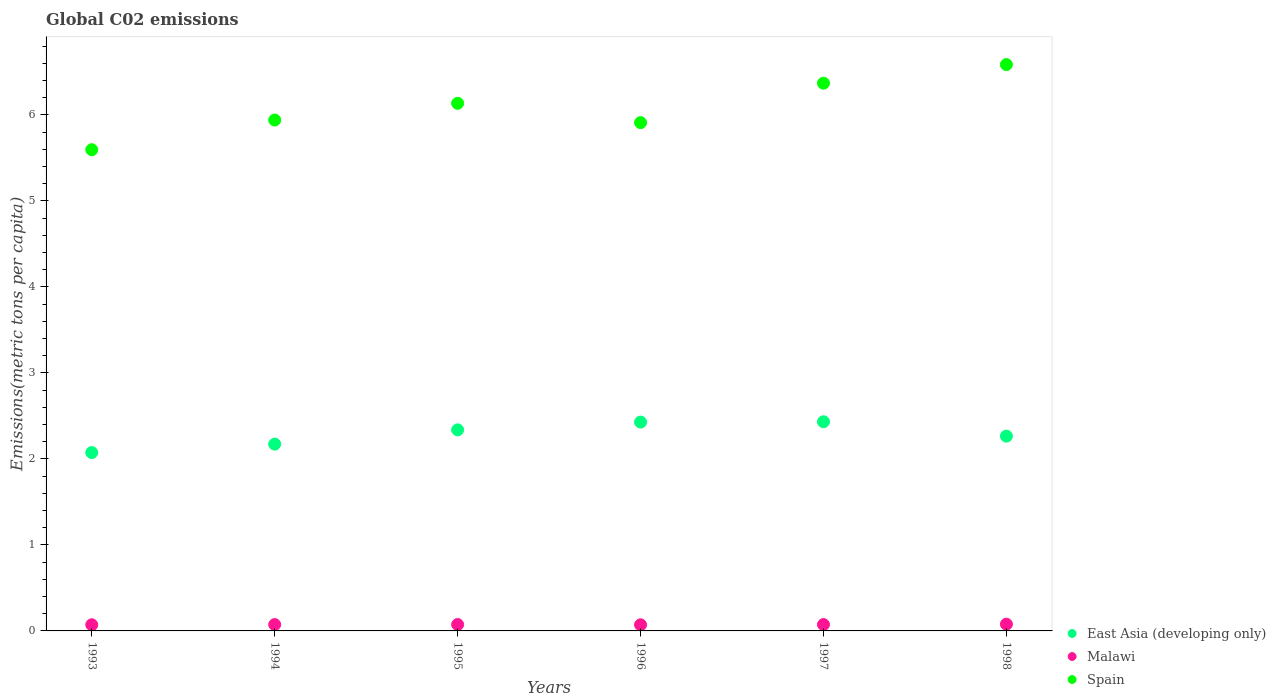How many different coloured dotlines are there?
Offer a very short reply. 3. What is the amount of CO2 emitted in in East Asia (developing only) in 1996?
Keep it short and to the point. 2.43. Across all years, what is the maximum amount of CO2 emitted in in Spain?
Your response must be concise. 6.58. Across all years, what is the minimum amount of CO2 emitted in in Malawi?
Ensure brevity in your answer.  0.07. In which year was the amount of CO2 emitted in in Spain maximum?
Offer a very short reply. 1998. What is the total amount of CO2 emitted in in Malawi in the graph?
Your answer should be very brief. 0.44. What is the difference between the amount of CO2 emitted in in Malawi in 1996 and that in 1998?
Your response must be concise. -0.01. What is the difference between the amount of CO2 emitted in in East Asia (developing only) in 1993 and the amount of CO2 emitted in in Malawi in 1998?
Make the answer very short. 2. What is the average amount of CO2 emitted in in East Asia (developing only) per year?
Your answer should be compact. 2.28. In the year 1998, what is the difference between the amount of CO2 emitted in in Malawi and amount of CO2 emitted in in East Asia (developing only)?
Ensure brevity in your answer.  -2.19. In how many years, is the amount of CO2 emitted in in East Asia (developing only) greater than 2.8 metric tons per capita?
Provide a short and direct response. 0. What is the ratio of the amount of CO2 emitted in in East Asia (developing only) in 1993 to that in 1994?
Provide a succinct answer. 0.95. Is the amount of CO2 emitted in in Malawi in 1993 less than that in 1995?
Your answer should be very brief. Yes. What is the difference between the highest and the second highest amount of CO2 emitted in in Malawi?
Give a very brief answer. 0. What is the difference between the highest and the lowest amount of CO2 emitted in in Malawi?
Your answer should be compact. 0.01. Does the amount of CO2 emitted in in Spain monotonically increase over the years?
Give a very brief answer. No. Where does the legend appear in the graph?
Your answer should be compact. Bottom right. What is the title of the graph?
Keep it short and to the point. Global C02 emissions. Does "Costa Rica" appear as one of the legend labels in the graph?
Provide a short and direct response. No. What is the label or title of the Y-axis?
Offer a very short reply. Emissions(metric tons per capita). What is the Emissions(metric tons per capita) in East Asia (developing only) in 1993?
Ensure brevity in your answer.  2.07. What is the Emissions(metric tons per capita) of Malawi in 1993?
Provide a succinct answer. 0.07. What is the Emissions(metric tons per capita) in Spain in 1993?
Give a very brief answer. 5.59. What is the Emissions(metric tons per capita) in East Asia (developing only) in 1994?
Give a very brief answer. 2.17. What is the Emissions(metric tons per capita) in Malawi in 1994?
Your answer should be compact. 0.07. What is the Emissions(metric tons per capita) in Spain in 1994?
Provide a succinct answer. 5.94. What is the Emissions(metric tons per capita) of East Asia (developing only) in 1995?
Your response must be concise. 2.34. What is the Emissions(metric tons per capita) of Malawi in 1995?
Ensure brevity in your answer.  0.07. What is the Emissions(metric tons per capita) of Spain in 1995?
Provide a short and direct response. 6.13. What is the Emissions(metric tons per capita) of East Asia (developing only) in 1996?
Provide a succinct answer. 2.43. What is the Emissions(metric tons per capita) in Malawi in 1996?
Offer a terse response. 0.07. What is the Emissions(metric tons per capita) of Spain in 1996?
Keep it short and to the point. 5.91. What is the Emissions(metric tons per capita) in East Asia (developing only) in 1997?
Your answer should be very brief. 2.43. What is the Emissions(metric tons per capita) of Malawi in 1997?
Provide a short and direct response. 0.07. What is the Emissions(metric tons per capita) of Spain in 1997?
Give a very brief answer. 6.37. What is the Emissions(metric tons per capita) in East Asia (developing only) in 1998?
Provide a short and direct response. 2.26. What is the Emissions(metric tons per capita) of Malawi in 1998?
Offer a terse response. 0.08. What is the Emissions(metric tons per capita) of Spain in 1998?
Offer a terse response. 6.58. Across all years, what is the maximum Emissions(metric tons per capita) of East Asia (developing only)?
Your answer should be very brief. 2.43. Across all years, what is the maximum Emissions(metric tons per capita) of Malawi?
Make the answer very short. 0.08. Across all years, what is the maximum Emissions(metric tons per capita) in Spain?
Provide a succinct answer. 6.58. Across all years, what is the minimum Emissions(metric tons per capita) of East Asia (developing only)?
Keep it short and to the point. 2.07. Across all years, what is the minimum Emissions(metric tons per capita) of Malawi?
Provide a short and direct response. 0.07. Across all years, what is the minimum Emissions(metric tons per capita) in Spain?
Provide a short and direct response. 5.59. What is the total Emissions(metric tons per capita) of East Asia (developing only) in the graph?
Your response must be concise. 13.71. What is the total Emissions(metric tons per capita) in Malawi in the graph?
Your response must be concise. 0.44. What is the total Emissions(metric tons per capita) of Spain in the graph?
Offer a terse response. 36.53. What is the difference between the Emissions(metric tons per capita) in East Asia (developing only) in 1993 and that in 1994?
Your response must be concise. -0.1. What is the difference between the Emissions(metric tons per capita) in Malawi in 1993 and that in 1994?
Your answer should be very brief. -0. What is the difference between the Emissions(metric tons per capita) of Spain in 1993 and that in 1994?
Give a very brief answer. -0.35. What is the difference between the Emissions(metric tons per capita) of East Asia (developing only) in 1993 and that in 1995?
Keep it short and to the point. -0.26. What is the difference between the Emissions(metric tons per capita) of Malawi in 1993 and that in 1995?
Provide a succinct answer. -0. What is the difference between the Emissions(metric tons per capita) in Spain in 1993 and that in 1995?
Keep it short and to the point. -0.54. What is the difference between the Emissions(metric tons per capita) in East Asia (developing only) in 1993 and that in 1996?
Offer a terse response. -0.35. What is the difference between the Emissions(metric tons per capita) of Malawi in 1993 and that in 1996?
Offer a very short reply. 0. What is the difference between the Emissions(metric tons per capita) of Spain in 1993 and that in 1996?
Your answer should be very brief. -0.32. What is the difference between the Emissions(metric tons per capita) in East Asia (developing only) in 1993 and that in 1997?
Your answer should be very brief. -0.36. What is the difference between the Emissions(metric tons per capita) of Malawi in 1993 and that in 1997?
Keep it short and to the point. -0. What is the difference between the Emissions(metric tons per capita) in Spain in 1993 and that in 1997?
Ensure brevity in your answer.  -0.77. What is the difference between the Emissions(metric tons per capita) of East Asia (developing only) in 1993 and that in 1998?
Your response must be concise. -0.19. What is the difference between the Emissions(metric tons per capita) of Malawi in 1993 and that in 1998?
Your response must be concise. -0.01. What is the difference between the Emissions(metric tons per capita) in Spain in 1993 and that in 1998?
Provide a short and direct response. -0.99. What is the difference between the Emissions(metric tons per capita) of East Asia (developing only) in 1994 and that in 1995?
Offer a terse response. -0.17. What is the difference between the Emissions(metric tons per capita) of Malawi in 1994 and that in 1995?
Your answer should be compact. -0. What is the difference between the Emissions(metric tons per capita) of Spain in 1994 and that in 1995?
Your answer should be very brief. -0.19. What is the difference between the Emissions(metric tons per capita) of East Asia (developing only) in 1994 and that in 1996?
Provide a short and direct response. -0.26. What is the difference between the Emissions(metric tons per capita) of Malawi in 1994 and that in 1996?
Provide a succinct answer. 0. What is the difference between the Emissions(metric tons per capita) of Spain in 1994 and that in 1996?
Ensure brevity in your answer.  0.03. What is the difference between the Emissions(metric tons per capita) of East Asia (developing only) in 1994 and that in 1997?
Make the answer very short. -0.26. What is the difference between the Emissions(metric tons per capita) of Malawi in 1994 and that in 1997?
Give a very brief answer. -0. What is the difference between the Emissions(metric tons per capita) of Spain in 1994 and that in 1997?
Ensure brevity in your answer.  -0.43. What is the difference between the Emissions(metric tons per capita) in East Asia (developing only) in 1994 and that in 1998?
Ensure brevity in your answer.  -0.09. What is the difference between the Emissions(metric tons per capita) in Malawi in 1994 and that in 1998?
Make the answer very short. -0. What is the difference between the Emissions(metric tons per capita) of Spain in 1994 and that in 1998?
Keep it short and to the point. -0.64. What is the difference between the Emissions(metric tons per capita) of East Asia (developing only) in 1995 and that in 1996?
Your answer should be very brief. -0.09. What is the difference between the Emissions(metric tons per capita) in Malawi in 1995 and that in 1996?
Ensure brevity in your answer.  0. What is the difference between the Emissions(metric tons per capita) of Spain in 1995 and that in 1996?
Provide a succinct answer. 0.22. What is the difference between the Emissions(metric tons per capita) in East Asia (developing only) in 1995 and that in 1997?
Provide a short and direct response. -0.09. What is the difference between the Emissions(metric tons per capita) of Spain in 1995 and that in 1997?
Ensure brevity in your answer.  -0.23. What is the difference between the Emissions(metric tons per capita) in East Asia (developing only) in 1995 and that in 1998?
Offer a very short reply. 0.07. What is the difference between the Emissions(metric tons per capita) of Malawi in 1995 and that in 1998?
Your answer should be compact. -0. What is the difference between the Emissions(metric tons per capita) in Spain in 1995 and that in 1998?
Offer a terse response. -0.45. What is the difference between the Emissions(metric tons per capita) of East Asia (developing only) in 1996 and that in 1997?
Keep it short and to the point. -0. What is the difference between the Emissions(metric tons per capita) of Malawi in 1996 and that in 1997?
Make the answer very short. -0. What is the difference between the Emissions(metric tons per capita) of Spain in 1996 and that in 1997?
Provide a short and direct response. -0.46. What is the difference between the Emissions(metric tons per capita) in East Asia (developing only) in 1996 and that in 1998?
Offer a terse response. 0.16. What is the difference between the Emissions(metric tons per capita) in Malawi in 1996 and that in 1998?
Your answer should be very brief. -0.01. What is the difference between the Emissions(metric tons per capita) in Spain in 1996 and that in 1998?
Your answer should be very brief. -0.67. What is the difference between the Emissions(metric tons per capita) in East Asia (developing only) in 1997 and that in 1998?
Your response must be concise. 0.17. What is the difference between the Emissions(metric tons per capita) of Malawi in 1997 and that in 1998?
Provide a short and direct response. -0. What is the difference between the Emissions(metric tons per capita) in Spain in 1997 and that in 1998?
Your answer should be very brief. -0.22. What is the difference between the Emissions(metric tons per capita) of East Asia (developing only) in 1993 and the Emissions(metric tons per capita) of Malawi in 1994?
Your answer should be compact. 2. What is the difference between the Emissions(metric tons per capita) in East Asia (developing only) in 1993 and the Emissions(metric tons per capita) in Spain in 1994?
Make the answer very short. -3.87. What is the difference between the Emissions(metric tons per capita) in Malawi in 1993 and the Emissions(metric tons per capita) in Spain in 1994?
Offer a very short reply. -5.87. What is the difference between the Emissions(metric tons per capita) in East Asia (developing only) in 1993 and the Emissions(metric tons per capita) in Malawi in 1995?
Your answer should be very brief. 2. What is the difference between the Emissions(metric tons per capita) in East Asia (developing only) in 1993 and the Emissions(metric tons per capita) in Spain in 1995?
Your answer should be compact. -4.06. What is the difference between the Emissions(metric tons per capita) of Malawi in 1993 and the Emissions(metric tons per capita) of Spain in 1995?
Give a very brief answer. -6.06. What is the difference between the Emissions(metric tons per capita) in East Asia (developing only) in 1993 and the Emissions(metric tons per capita) in Malawi in 1996?
Your answer should be very brief. 2. What is the difference between the Emissions(metric tons per capita) in East Asia (developing only) in 1993 and the Emissions(metric tons per capita) in Spain in 1996?
Ensure brevity in your answer.  -3.84. What is the difference between the Emissions(metric tons per capita) of Malawi in 1993 and the Emissions(metric tons per capita) of Spain in 1996?
Offer a very short reply. -5.84. What is the difference between the Emissions(metric tons per capita) of East Asia (developing only) in 1993 and the Emissions(metric tons per capita) of Malawi in 1997?
Provide a short and direct response. 2. What is the difference between the Emissions(metric tons per capita) of East Asia (developing only) in 1993 and the Emissions(metric tons per capita) of Spain in 1997?
Provide a succinct answer. -4.29. What is the difference between the Emissions(metric tons per capita) of Malawi in 1993 and the Emissions(metric tons per capita) of Spain in 1997?
Your answer should be compact. -6.3. What is the difference between the Emissions(metric tons per capita) of East Asia (developing only) in 1993 and the Emissions(metric tons per capita) of Malawi in 1998?
Provide a succinct answer. 2. What is the difference between the Emissions(metric tons per capita) in East Asia (developing only) in 1993 and the Emissions(metric tons per capita) in Spain in 1998?
Your answer should be compact. -4.51. What is the difference between the Emissions(metric tons per capita) of Malawi in 1993 and the Emissions(metric tons per capita) of Spain in 1998?
Give a very brief answer. -6.51. What is the difference between the Emissions(metric tons per capita) in East Asia (developing only) in 1994 and the Emissions(metric tons per capita) in Malawi in 1995?
Provide a short and direct response. 2.1. What is the difference between the Emissions(metric tons per capita) of East Asia (developing only) in 1994 and the Emissions(metric tons per capita) of Spain in 1995?
Your response must be concise. -3.96. What is the difference between the Emissions(metric tons per capita) in Malawi in 1994 and the Emissions(metric tons per capita) in Spain in 1995?
Make the answer very short. -6.06. What is the difference between the Emissions(metric tons per capita) in East Asia (developing only) in 1994 and the Emissions(metric tons per capita) in Malawi in 1996?
Your response must be concise. 2.1. What is the difference between the Emissions(metric tons per capita) of East Asia (developing only) in 1994 and the Emissions(metric tons per capita) of Spain in 1996?
Your answer should be very brief. -3.74. What is the difference between the Emissions(metric tons per capita) in Malawi in 1994 and the Emissions(metric tons per capita) in Spain in 1996?
Your answer should be compact. -5.84. What is the difference between the Emissions(metric tons per capita) of East Asia (developing only) in 1994 and the Emissions(metric tons per capita) of Malawi in 1997?
Make the answer very short. 2.1. What is the difference between the Emissions(metric tons per capita) in East Asia (developing only) in 1994 and the Emissions(metric tons per capita) in Spain in 1997?
Provide a succinct answer. -4.2. What is the difference between the Emissions(metric tons per capita) in Malawi in 1994 and the Emissions(metric tons per capita) in Spain in 1997?
Your response must be concise. -6.29. What is the difference between the Emissions(metric tons per capita) in East Asia (developing only) in 1994 and the Emissions(metric tons per capita) in Malawi in 1998?
Provide a short and direct response. 2.09. What is the difference between the Emissions(metric tons per capita) of East Asia (developing only) in 1994 and the Emissions(metric tons per capita) of Spain in 1998?
Give a very brief answer. -4.41. What is the difference between the Emissions(metric tons per capita) of Malawi in 1994 and the Emissions(metric tons per capita) of Spain in 1998?
Offer a terse response. -6.51. What is the difference between the Emissions(metric tons per capita) in East Asia (developing only) in 1995 and the Emissions(metric tons per capita) in Malawi in 1996?
Provide a succinct answer. 2.27. What is the difference between the Emissions(metric tons per capita) in East Asia (developing only) in 1995 and the Emissions(metric tons per capita) in Spain in 1996?
Your response must be concise. -3.57. What is the difference between the Emissions(metric tons per capita) in Malawi in 1995 and the Emissions(metric tons per capita) in Spain in 1996?
Your answer should be compact. -5.84. What is the difference between the Emissions(metric tons per capita) in East Asia (developing only) in 1995 and the Emissions(metric tons per capita) in Malawi in 1997?
Provide a succinct answer. 2.26. What is the difference between the Emissions(metric tons per capita) of East Asia (developing only) in 1995 and the Emissions(metric tons per capita) of Spain in 1997?
Provide a succinct answer. -4.03. What is the difference between the Emissions(metric tons per capita) in Malawi in 1995 and the Emissions(metric tons per capita) in Spain in 1997?
Provide a succinct answer. -6.29. What is the difference between the Emissions(metric tons per capita) of East Asia (developing only) in 1995 and the Emissions(metric tons per capita) of Malawi in 1998?
Keep it short and to the point. 2.26. What is the difference between the Emissions(metric tons per capita) of East Asia (developing only) in 1995 and the Emissions(metric tons per capita) of Spain in 1998?
Your answer should be very brief. -4.25. What is the difference between the Emissions(metric tons per capita) in Malawi in 1995 and the Emissions(metric tons per capita) in Spain in 1998?
Offer a very short reply. -6.51. What is the difference between the Emissions(metric tons per capita) in East Asia (developing only) in 1996 and the Emissions(metric tons per capita) in Malawi in 1997?
Your answer should be very brief. 2.35. What is the difference between the Emissions(metric tons per capita) of East Asia (developing only) in 1996 and the Emissions(metric tons per capita) of Spain in 1997?
Give a very brief answer. -3.94. What is the difference between the Emissions(metric tons per capita) of Malawi in 1996 and the Emissions(metric tons per capita) of Spain in 1997?
Your answer should be very brief. -6.3. What is the difference between the Emissions(metric tons per capita) in East Asia (developing only) in 1996 and the Emissions(metric tons per capita) in Malawi in 1998?
Your response must be concise. 2.35. What is the difference between the Emissions(metric tons per capita) of East Asia (developing only) in 1996 and the Emissions(metric tons per capita) of Spain in 1998?
Offer a very short reply. -4.16. What is the difference between the Emissions(metric tons per capita) of Malawi in 1996 and the Emissions(metric tons per capita) of Spain in 1998?
Offer a very short reply. -6.51. What is the difference between the Emissions(metric tons per capita) in East Asia (developing only) in 1997 and the Emissions(metric tons per capita) in Malawi in 1998?
Ensure brevity in your answer.  2.35. What is the difference between the Emissions(metric tons per capita) of East Asia (developing only) in 1997 and the Emissions(metric tons per capita) of Spain in 1998?
Keep it short and to the point. -4.15. What is the difference between the Emissions(metric tons per capita) in Malawi in 1997 and the Emissions(metric tons per capita) in Spain in 1998?
Your answer should be very brief. -6.51. What is the average Emissions(metric tons per capita) in East Asia (developing only) per year?
Provide a short and direct response. 2.28. What is the average Emissions(metric tons per capita) of Malawi per year?
Make the answer very short. 0.07. What is the average Emissions(metric tons per capita) of Spain per year?
Provide a succinct answer. 6.09. In the year 1993, what is the difference between the Emissions(metric tons per capita) of East Asia (developing only) and Emissions(metric tons per capita) of Malawi?
Provide a succinct answer. 2. In the year 1993, what is the difference between the Emissions(metric tons per capita) of East Asia (developing only) and Emissions(metric tons per capita) of Spain?
Your response must be concise. -3.52. In the year 1993, what is the difference between the Emissions(metric tons per capita) in Malawi and Emissions(metric tons per capita) in Spain?
Give a very brief answer. -5.52. In the year 1994, what is the difference between the Emissions(metric tons per capita) in East Asia (developing only) and Emissions(metric tons per capita) in Malawi?
Ensure brevity in your answer.  2.1. In the year 1994, what is the difference between the Emissions(metric tons per capita) of East Asia (developing only) and Emissions(metric tons per capita) of Spain?
Provide a succinct answer. -3.77. In the year 1994, what is the difference between the Emissions(metric tons per capita) of Malawi and Emissions(metric tons per capita) of Spain?
Keep it short and to the point. -5.87. In the year 1995, what is the difference between the Emissions(metric tons per capita) in East Asia (developing only) and Emissions(metric tons per capita) in Malawi?
Keep it short and to the point. 2.26. In the year 1995, what is the difference between the Emissions(metric tons per capita) in East Asia (developing only) and Emissions(metric tons per capita) in Spain?
Your answer should be compact. -3.8. In the year 1995, what is the difference between the Emissions(metric tons per capita) of Malawi and Emissions(metric tons per capita) of Spain?
Provide a short and direct response. -6.06. In the year 1996, what is the difference between the Emissions(metric tons per capita) of East Asia (developing only) and Emissions(metric tons per capita) of Malawi?
Give a very brief answer. 2.36. In the year 1996, what is the difference between the Emissions(metric tons per capita) of East Asia (developing only) and Emissions(metric tons per capita) of Spain?
Give a very brief answer. -3.48. In the year 1996, what is the difference between the Emissions(metric tons per capita) in Malawi and Emissions(metric tons per capita) in Spain?
Provide a short and direct response. -5.84. In the year 1997, what is the difference between the Emissions(metric tons per capita) of East Asia (developing only) and Emissions(metric tons per capita) of Malawi?
Give a very brief answer. 2.36. In the year 1997, what is the difference between the Emissions(metric tons per capita) of East Asia (developing only) and Emissions(metric tons per capita) of Spain?
Keep it short and to the point. -3.94. In the year 1997, what is the difference between the Emissions(metric tons per capita) of Malawi and Emissions(metric tons per capita) of Spain?
Your answer should be very brief. -6.29. In the year 1998, what is the difference between the Emissions(metric tons per capita) in East Asia (developing only) and Emissions(metric tons per capita) in Malawi?
Make the answer very short. 2.19. In the year 1998, what is the difference between the Emissions(metric tons per capita) in East Asia (developing only) and Emissions(metric tons per capita) in Spain?
Ensure brevity in your answer.  -4.32. In the year 1998, what is the difference between the Emissions(metric tons per capita) in Malawi and Emissions(metric tons per capita) in Spain?
Keep it short and to the point. -6.51. What is the ratio of the Emissions(metric tons per capita) of East Asia (developing only) in 1993 to that in 1994?
Ensure brevity in your answer.  0.95. What is the ratio of the Emissions(metric tons per capita) of Malawi in 1993 to that in 1994?
Offer a terse response. 0.97. What is the ratio of the Emissions(metric tons per capita) of Spain in 1993 to that in 1994?
Offer a terse response. 0.94. What is the ratio of the Emissions(metric tons per capita) in East Asia (developing only) in 1993 to that in 1995?
Your answer should be very brief. 0.89. What is the ratio of the Emissions(metric tons per capita) of Spain in 1993 to that in 1995?
Ensure brevity in your answer.  0.91. What is the ratio of the Emissions(metric tons per capita) of East Asia (developing only) in 1993 to that in 1996?
Offer a very short reply. 0.85. What is the ratio of the Emissions(metric tons per capita) in Malawi in 1993 to that in 1996?
Provide a short and direct response. 1.01. What is the ratio of the Emissions(metric tons per capita) in Spain in 1993 to that in 1996?
Offer a very short reply. 0.95. What is the ratio of the Emissions(metric tons per capita) of East Asia (developing only) in 1993 to that in 1997?
Your answer should be very brief. 0.85. What is the ratio of the Emissions(metric tons per capita) of Malawi in 1993 to that in 1997?
Keep it short and to the point. 0.97. What is the ratio of the Emissions(metric tons per capita) in Spain in 1993 to that in 1997?
Your response must be concise. 0.88. What is the ratio of the Emissions(metric tons per capita) of East Asia (developing only) in 1993 to that in 1998?
Keep it short and to the point. 0.92. What is the ratio of the Emissions(metric tons per capita) of Malawi in 1993 to that in 1998?
Give a very brief answer. 0.91. What is the ratio of the Emissions(metric tons per capita) in Spain in 1993 to that in 1998?
Your answer should be very brief. 0.85. What is the ratio of the Emissions(metric tons per capita) in East Asia (developing only) in 1994 to that in 1995?
Ensure brevity in your answer.  0.93. What is the ratio of the Emissions(metric tons per capita) of Malawi in 1994 to that in 1995?
Offer a terse response. 0.99. What is the ratio of the Emissions(metric tons per capita) in Spain in 1994 to that in 1995?
Offer a terse response. 0.97. What is the ratio of the Emissions(metric tons per capita) in East Asia (developing only) in 1994 to that in 1996?
Ensure brevity in your answer.  0.89. What is the ratio of the Emissions(metric tons per capita) in Malawi in 1994 to that in 1996?
Offer a terse response. 1.04. What is the ratio of the Emissions(metric tons per capita) of Spain in 1994 to that in 1996?
Give a very brief answer. 1.01. What is the ratio of the Emissions(metric tons per capita) of East Asia (developing only) in 1994 to that in 1997?
Make the answer very short. 0.89. What is the ratio of the Emissions(metric tons per capita) of Malawi in 1994 to that in 1997?
Your response must be concise. 1. What is the ratio of the Emissions(metric tons per capita) of Spain in 1994 to that in 1997?
Your response must be concise. 0.93. What is the ratio of the Emissions(metric tons per capita) of East Asia (developing only) in 1994 to that in 1998?
Provide a short and direct response. 0.96. What is the ratio of the Emissions(metric tons per capita) of Malawi in 1994 to that in 1998?
Your response must be concise. 0.94. What is the ratio of the Emissions(metric tons per capita) of Spain in 1994 to that in 1998?
Your answer should be very brief. 0.9. What is the ratio of the Emissions(metric tons per capita) in East Asia (developing only) in 1995 to that in 1996?
Offer a terse response. 0.96. What is the ratio of the Emissions(metric tons per capita) of Malawi in 1995 to that in 1996?
Offer a terse response. 1.04. What is the ratio of the Emissions(metric tons per capita) of Spain in 1995 to that in 1996?
Your answer should be compact. 1.04. What is the ratio of the Emissions(metric tons per capita) of East Asia (developing only) in 1995 to that in 1997?
Provide a succinct answer. 0.96. What is the ratio of the Emissions(metric tons per capita) of Spain in 1995 to that in 1997?
Provide a short and direct response. 0.96. What is the ratio of the Emissions(metric tons per capita) of East Asia (developing only) in 1995 to that in 1998?
Keep it short and to the point. 1.03. What is the ratio of the Emissions(metric tons per capita) of Malawi in 1995 to that in 1998?
Provide a short and direct response. 0.95. What is the ratio of the Emissions(metric tons per capita) in Spain in 1995 to that in 1998?
Provide a short and direct response. 0.93. What is the ratio of the Emissions(metric tons per capita) of East Asia (developing only) in 1996 to that in 1997?
Offer a very short reply. 1. What is the ratio of the Emissions(metric tons per capita) of Spain in 1996 to that in 1997?
Offer a very short reply. 0.93. What is the ratio of the Emissions(metric tons per capita) in East Asia (developing only) in 1996 to that in 1998?
Your answer should be compact. 1.07. What is the ratio of the Emissions(metric tons per capita) in Malawi in 1996 to that in 1998?
Ensure brevity in your answer.  0.91. What is the ratio of the Emissions(metric tons per capita) in Spain in 1996 to that in 1998?
Offer a very short reply. 0.9. What is the ratio of the Emissions(metric tons per capita) of East Asia (developing only) in 1997 to that in 1998?
Ensure brevity in your answer.  1.07. What is the ratio of the Emissions(metric tons per capita) of Malawi in 1997 to that in 1998?
Provide a succinct answer. 0.94. What is the ratio of the Emissions(metric tons per capita) in Spain in 1997 to that in 1998?
Keep it short and to the point. 0.97. What is the difference between the highest and the second highest Emissions(metric tons per capita) in East Asia (developing only)?
Your answer should be very brief. 0. What is the difference between the highest and the second highest Emissions(metric tons per capita) in Malawi?
Provide a short and direct response. 0. What is the difference between the highest and the second highest Emissions(metric tons per capita) of Spain?
Your answer should be compact. 0.22. What is the difference between the highest and the lowest Emissions(metric tons per capita) of East Asia (developing only)?
Make the answer very short. 0.36. What is the difference between the highest and the lowest Emissions(metric tons per capita) of Malawi?
Keep it short and to the point. 0.01. What is the difference between the highest and the lowest Emissions(metric tons per capita) in Spain?
Your response must be concise. 0.99. 